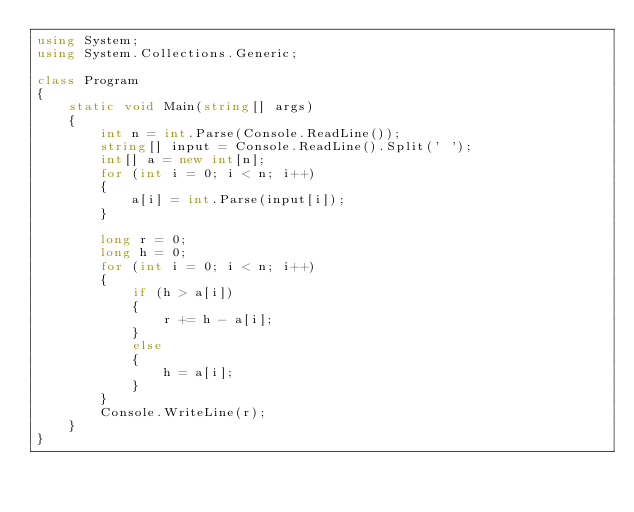Convert code to text. <code><loc_0><loc_0><loc_500><loc_500><_C#_>using System;
using System.Collections.Generic;

class Program
{
    static void Main(string[] args)
    {
        int n = int.Parse(Console.ReadLine());
        string[] input = Console.ReadLine().Split(' ');
        int[] a = new int[n];
        for (int i = 0; i < n; i++)
        {
            a[i] = int.Parse(input[i]);
        }

        long r = 0;
        long h = 0;
        for (int i = 0; i < n; i++)
        {
            if (h > a[i])
            {
                r += h - a[i];
            }
            else
            {
                h = a[i];
            }
        }
        Console.WriteLine(r);
    }
}</code> 